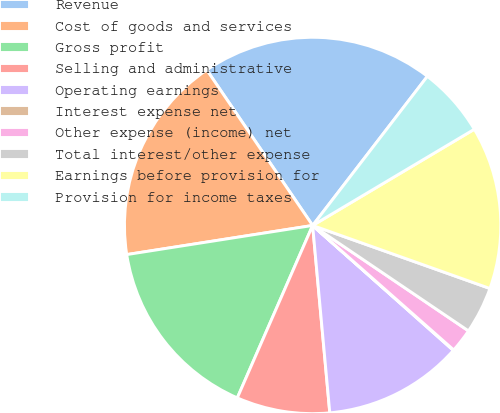Convert chart. <chart><loc_0><loc_0><loc_500><loc_500><pie_chart><fcel>Revenue<fcel>Cost of goods and services<fcel>Gross profit<fcel>Selling and administrative<fcel>Operating earnings<fcel>Interest expense net<fcel>Other expense (income) net<fcel>Total interest/other expense<fcel>Earnings before provision for<fcel>Provision for income taxes<nl><fcel>19.95%<fcel>17.96%<fcel>15.97%<fcel>8.01%<fcel>11.99%<fcel>0.05%<fcel>2.04%<fcel>4.03%<fcel>13.98%<fcel>6.02%<nl></chart> 